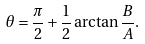Convert formula to latex. <formula><loc_0><loc_0><loc_500><loc_500>\theta = \frac { \pi } { 2 } + \frac { 1 } { 2 } \arctan \frac { B } { A } .</formula> 